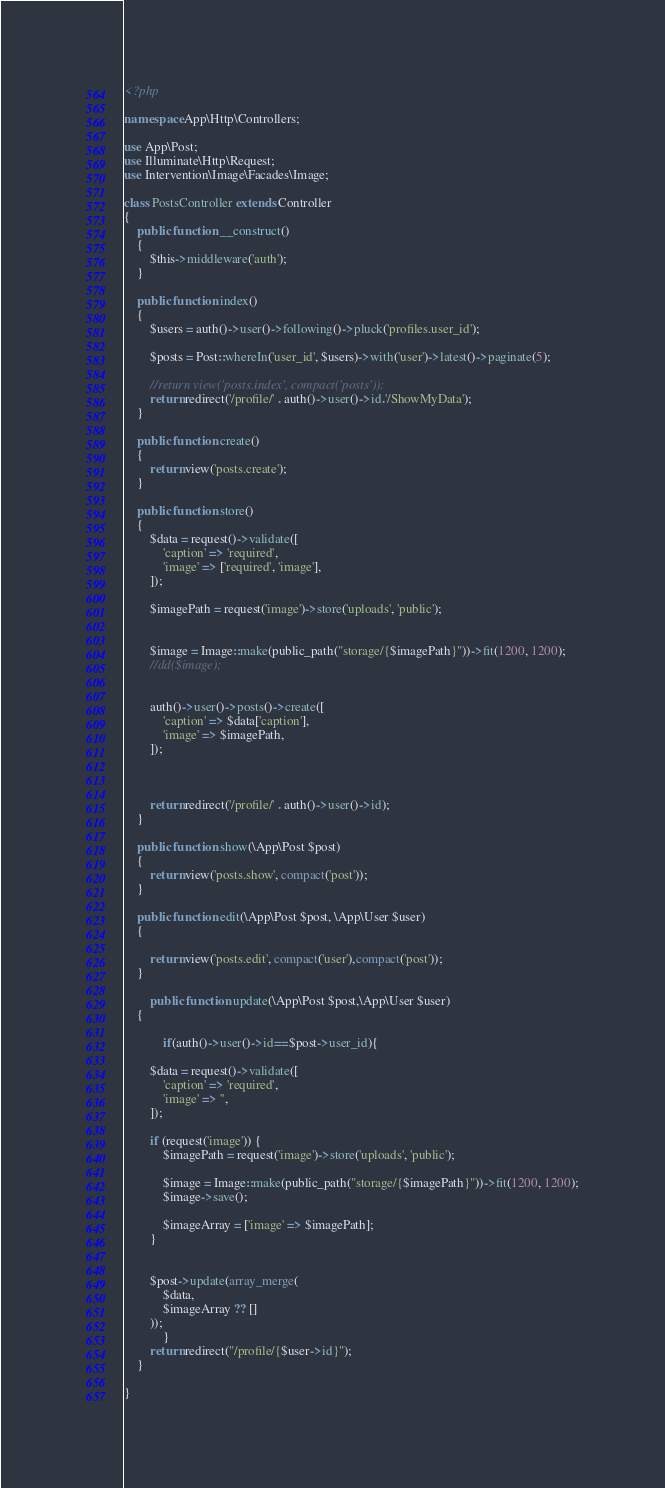Convert code to text. <code><loc_0><loc_0><loc_500><loc_500><_PHP_><?php

namespace App\Http\Controllers;

use App\Post;
use Illuminate\Http\Request;
use Intervention\Image\Facades\Image;

class PostsController extends Controller
{
    public function __construct()
    {
        $this->middleware('auth');
    }

    public function index()
    {
        $users = auth()->user()->following()->pluck('profiles.user_id');

        $posts = Post::whereIn('user_id', $users)->with('user')->latest()->paginate(5);

        //return view('posts.index', compact('posts'));
        return redirect('/profile/' . auth()->user()->id.'/ShowMyData');
    }

    public function create()
    {
        return view('posts.create');
    }

    public function store()
    {
        $data = request()->validate([
            'caption' => 'required',
            'image' => ['required', 'image'],
        ]);

        $imagePath = request('image')->store('uploads', 'public');
       

        $image = Image::make(public_path("storage/{$imagePath}"))->fit(1200, 1200);
        //dd($image);
       

        auth()->user()->posts()->create([
            'caption' => $data['caption'],
            'image' => $imagePath,
        ]);
        
        

        return redirect('/profile/' . auth()->user()->id);
    }

    public function show(\App\Post $post)
    {
        return view('posts.show', compact('post'));
    }
    
    public function edit(\App\Post $post, \App\User $user)
    {
       
        return view('posts.edit', compact('user'),compact('post'));
    }
    
        public function update(\App\Post $post,\App\User $user)
    {
      
            if(auth()->user()->id==$post->user_id){

        $data = request()->validate([
            'caption' => 'required',
            'image' => '',
        ]);

        if (request('image')) {
            $imagePath = request('image')->store('uploads', 'public');

            $image = Image::make(public_path("storage/{$imagePath}"))->fit(1200, 1200);
            $image->save();

            $imageArray = ['image' => $imagePath];
        }
        
        
        $post->update(array_merge(
            $data,
            $imageArray ?? []
        ));
            }
        return redirect("/profile/{$user->id}");
    }
    
}
</code> 